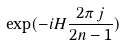<formula> <loc_0><loc_0><loc_500><loc_500>\exp ( - i H \frac { 2 \pi \, j } { 2 n - 1 } )</formula> 